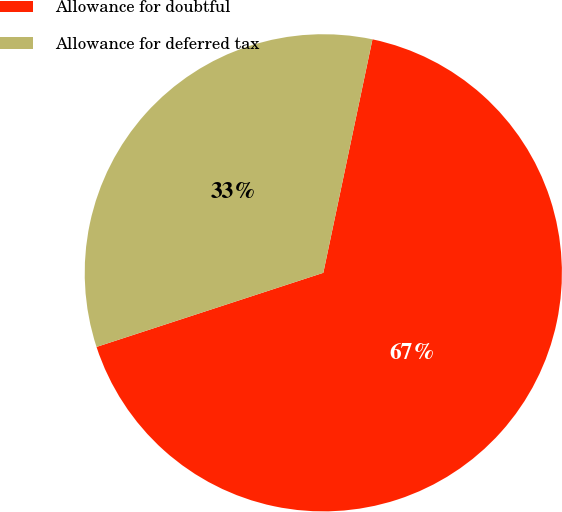Convert chart to OTSL. <chart><loc_0><loc_0><loc_500><loc_500><pie_chart><fcel>Allowance for doubtful<fcel>Allowance for deferred tax<nl><fcel>66.67%<fcel>33.33%<nl></chart> 